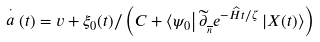<formula> <loc_0><loc_0><loc_500><loc_500>\stackrel { \cdot } { a } ( t ) = v + \xi _ { 0 } ( t ) / \left ( C + \left \langle \psi _ { 0 } \right | \widetilde { \partial } _ { _ { \overline { n } } } e ^ { - \widehat { H } t / \zeta } \left | X ( t ) \right \rangle \right )</formula> 